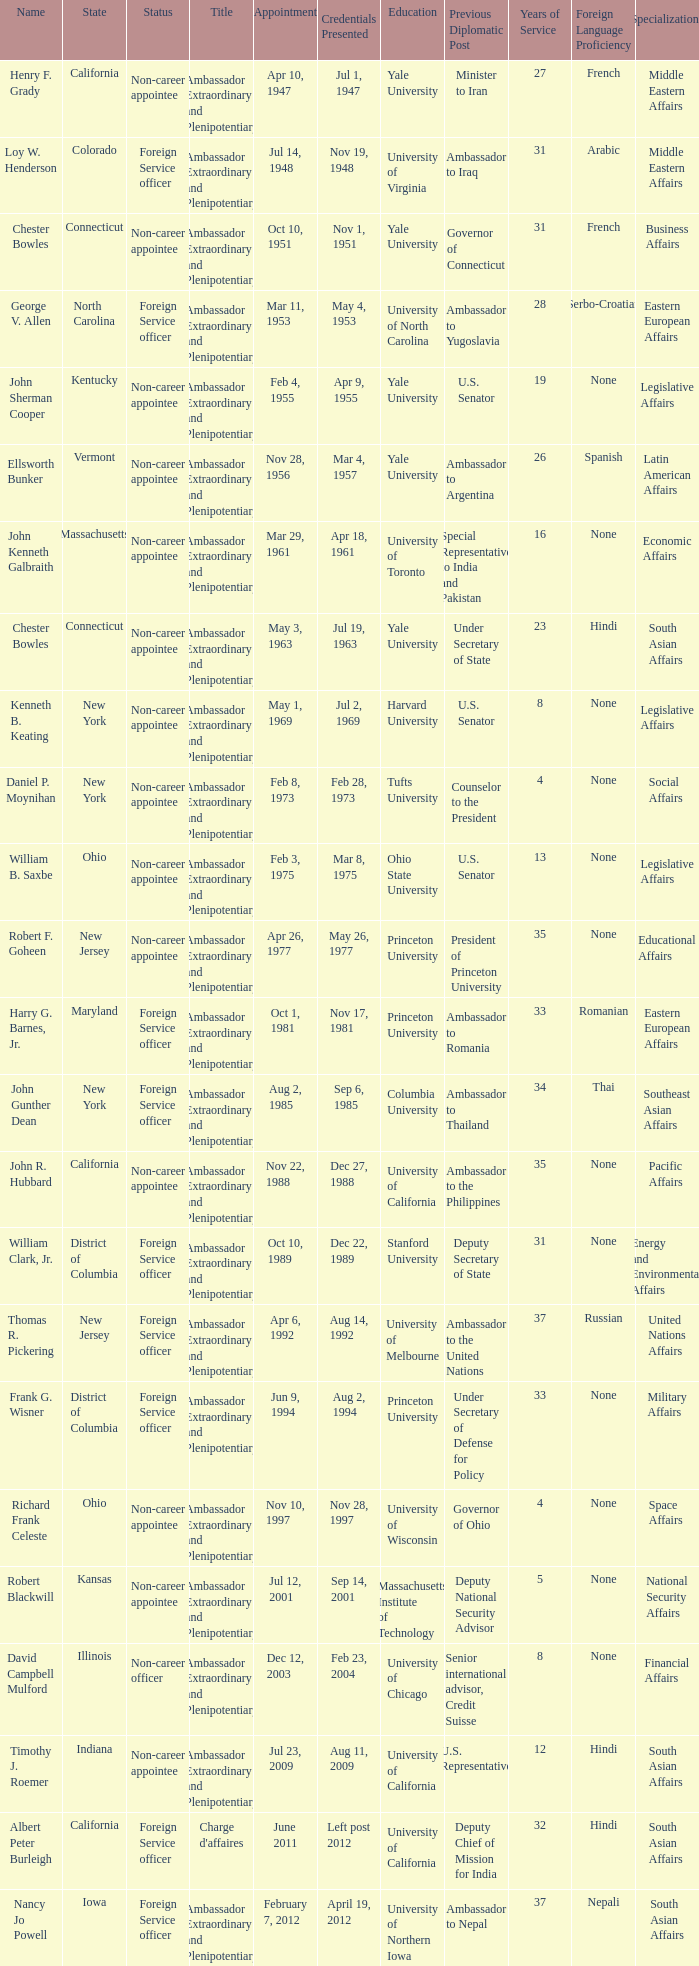What is the title for david campbell mulford? Ambassador Extraordinary and Plenipotentiary. 